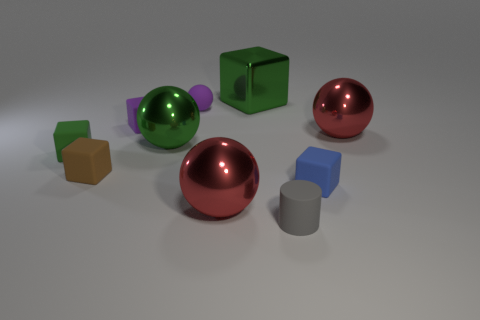How many rubber objects are either small gray balls or tiny brown things?
Your response must be concise. 1. How big is the red sphere that is to the right of the green thing that is behind the green sphere?
Offer a terse response. Large. Do the big metallic ball on the left side of the small purple ball and the metal thing on the right side of the cylinder have the same color?
Your response must be concise. No. What is the color of the thing that is in front of the small blue object and behind the small cylinder?
Offer a very short reply. Red. Is the small brown thing made of the same material as the gray object?
Give a very brief answer. Yes. How many large objects are metal balls or gray matte objects?
Your answer should be very brief. 3. Is there anything else that is the same shape as the blue object?
Give a very brief answer. Yes. Are there any other things that are the same size as the matte cylinder?
Offer a terse response. Yes. There is a cylinder that is the same material as the tiny ball; what is its color?
Your response must be concise. Gray. What color is the cylinder that is right of the green ball?
Ensure brevity in your answer.  Gray. 